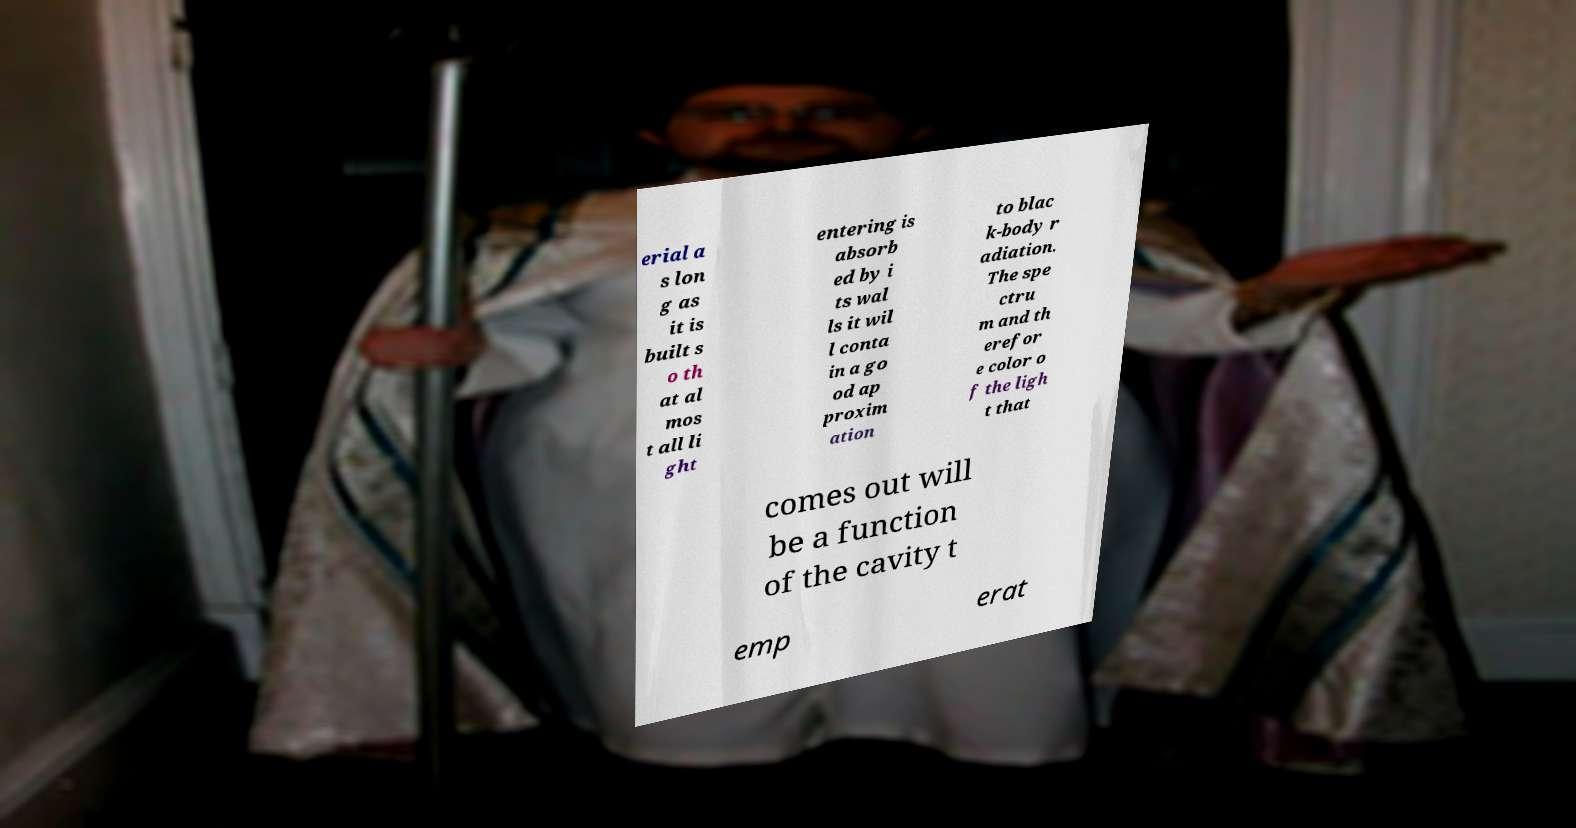Can you accurately transcribe the text from the provided image for me? erial a s lon g as it is built s o th at al mos t all li ght entering is absorb ed by i ts wal ls it wil l conta in a go od ap proxim ation to blac k-body r adiation. The spe ctru m and th erefor e color o f the ligh t that comes out will be a function of the cavity t emp erat 